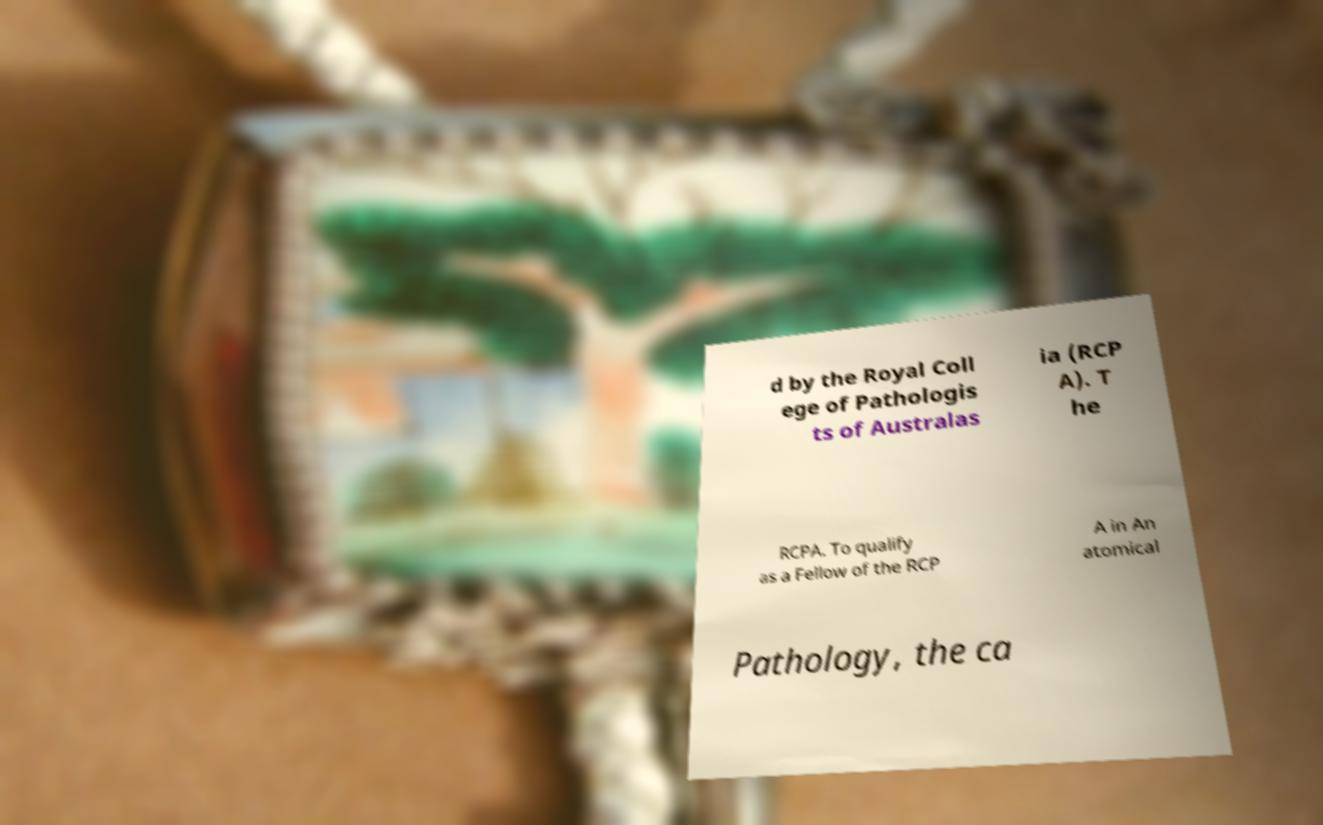Please identify and transcribe the text found in this image. d by the Royal Coll ege of Pathologis ts of Australas ia (RCP A). T he RCPA. To qualify as a Fellow of the RCP A in An atomical Pathology, the ca 